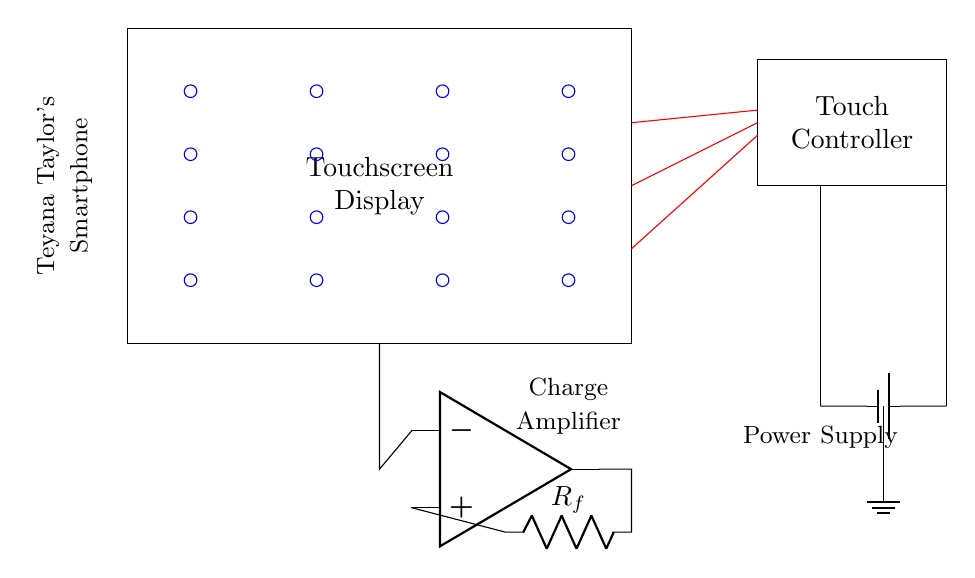what component is used to sense touch? The circuit diagram shows a grid of blue circles representing capacitive sensors, which are used to detect touch by measuring changes in capacitance when a finger is near.
Answer: capacitive sensors what type of circuit is this? The circuit includes touch sensors and a controller, which are characteristics of a touchscreen sensing circuit, especially for mobile devices like smartphones.
Answer: touchscreen sensing circuit how many capacitive sensors are shown? There are eight blue circles arranged in a grid, which represent the capacitive sensors used for touch detection on the display.
Answer: eight what is the role of the touch controller? The touch controller interprets the signals from the capacitive sensors and translates them into touch events that the smartphone can understand.
Answer: interpreting touch signals what does the charge amplifier do in this circuit? The charge amplifier takes the small capacitive sensor signals and amplifies them to a level that can be processed by the touch controller, ensuring accurate touch detection.
Answer: amplifies sensor signals which component provides power to the circuit? The power supply is depicted as a battery symbol, providing the necessary voltage to the entire circuit for operation.
Answer: battery what happens if the touchscreen display is not properly calibrated? If not calibrated, the touchscreen may not accurately register touches, leading to incorrect input detection or unresponsive areas on the screen.
Answer: inaccurate touch detection 